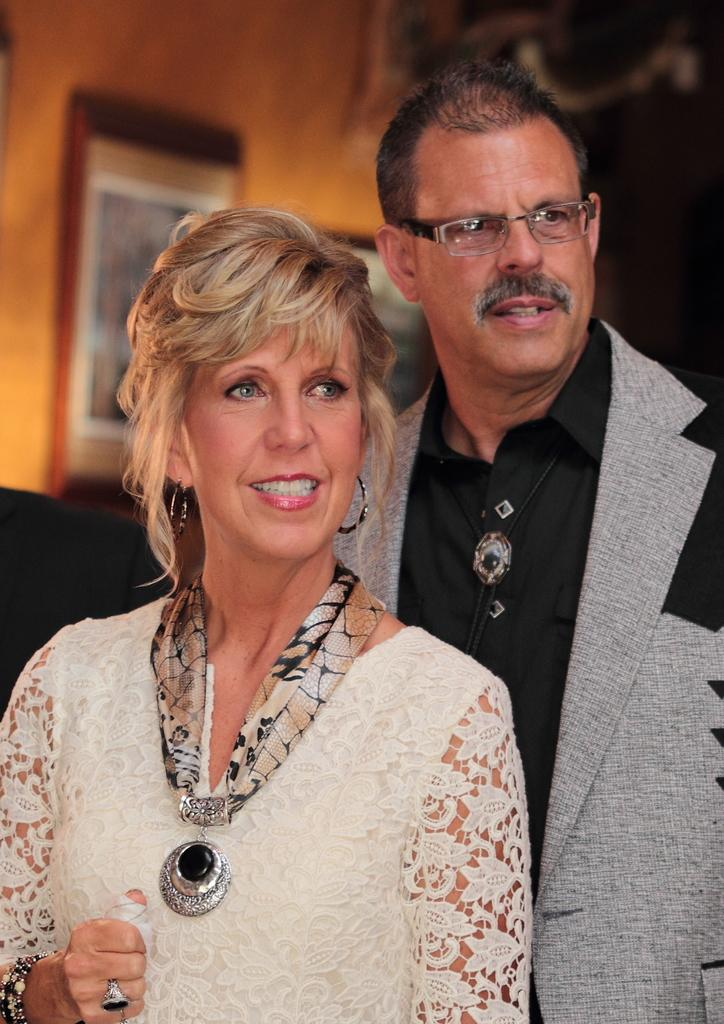How many people are present in the image? There is a man and a woman in the image. What can be seen on the wall in the image? There are photo frames on the wall in the image. Can you describe the background of the image? The background of the image is blurred. Where is the kitten playing with the hydrant in the image? There is no kitten or hydrant present in the image. What is the couple's shared interest in the image? The provided facts do not mention any shared interests between the man and the woman in the image. 